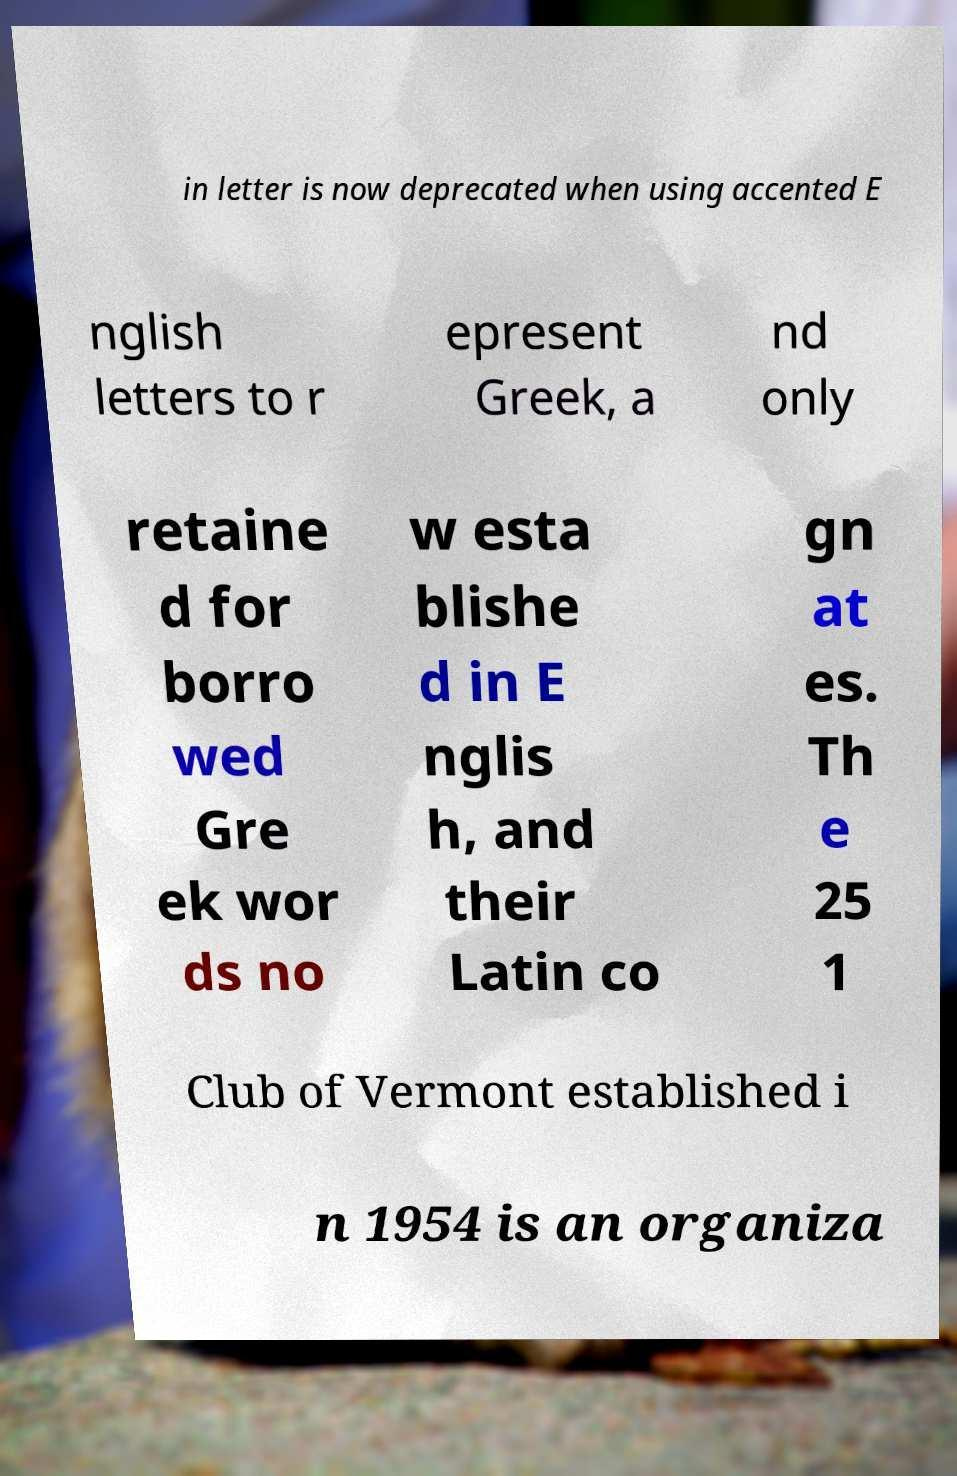Could you assist in decoding the text presented in this image and type it out clearly? in letter is now deprecated when using accented E nglish letters to r epresent Greek, a nd only retaine d for borro wed Gre ek wor ds no w esta blishe d in E nglis h, and their Latin co gn at es. Th e 25 1 Club of Vermont established i n 1954 is an organiza 